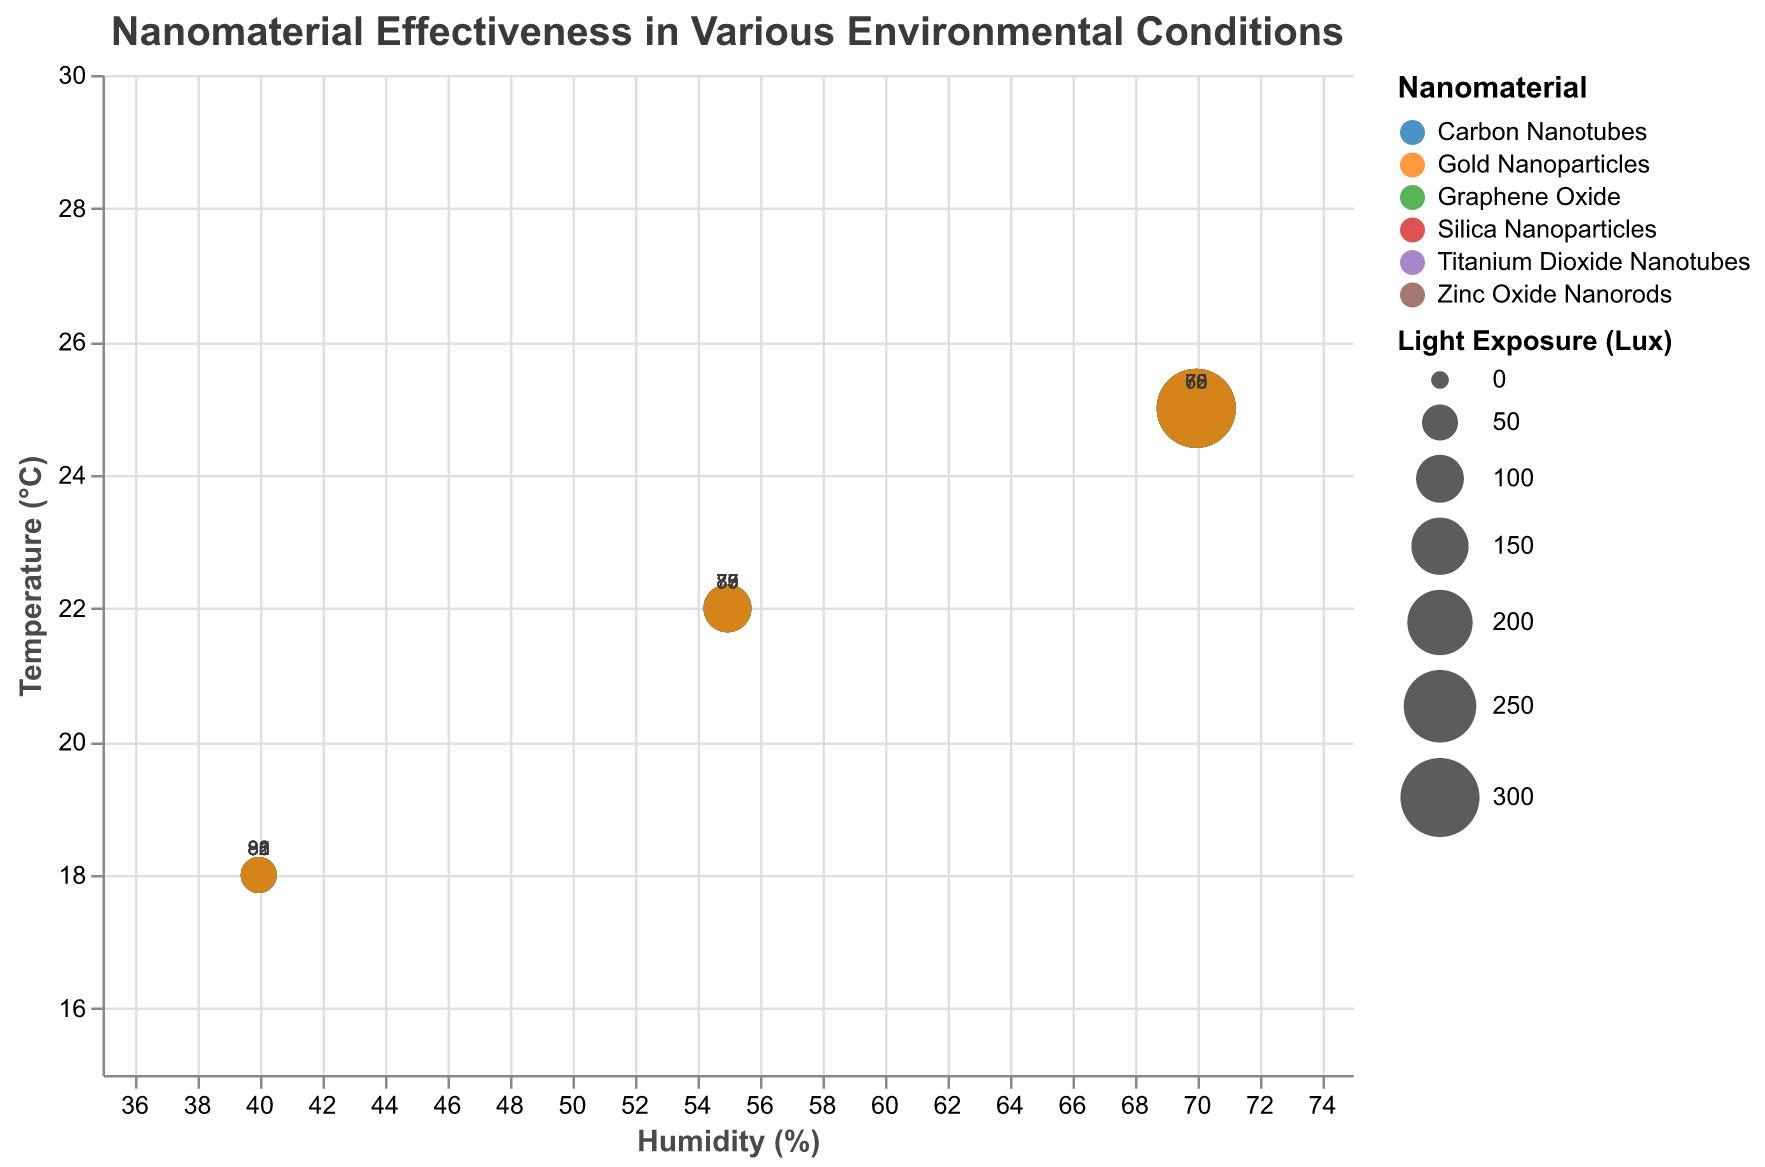What is the title of the figure? The title is typically found at the top of the chart and clearly states the purpose of the visualization.
Answer: "Nanomaterial Effectiveness in Various Environmental Conditions" What are the units of measurement used for the Y-axis? The units can be understood by reading the Y-axis label that provides information about the variable and its measurement unit.
Answer: °C Which nanomaterial has the highest effectiveness score at 40% humidity and 18°C temperature? Locate the points corresponding to 40% humidity and 18°C temperature and then identify the material with the highest effectiveness score among them.
Answer: Graphene Oxide How does the effectiveness score of Silica Nanoparticles change from 40% humidity to 70% humidity at a constant temperature of 18°C? Compare the effectiveness scores of Silica Nanoparticles at 40% and 70% humidity while keeping the temperature constant at 18°C and describe the change.
Answer: Decreases from 85 to 76 Which material has the largest bubble size at 70% humidity and 25°C temperature, and what does this imply about its light exposure? Find the material at 70% humidity and 25°C temperature with the largest bubble. The bubble size indicates the extent of light exposure.
Answer: Silica Nanoparticles; high light exposure (300 Lux) How many different types of nanomaterials are represented in the figure? Look at the legend or count distinct colors representing different nanomaterials in the chart.
Answer: 6 Which material shows the greatest variability in effectiveness scores across different environmental conditions? Compare the range of effectiveness scores for each material across all environmental conditions presented in the data.
Answer: Graphene Oxide At 55% humidity and 22°C temperature, which nanomaterial has the smallest bubble size and what is its light exposure? Locate the point corresponding to 55% humidity and 22°C temperature. Find the material with the smallest bubble size and note its light exposure.
Answer: Silica Nanoparticles; 100 Lux What general trend can be observed about the effectiveness of nanomaterials when humidity increases from 40% to 70% while the temperature is maintained at 25°C? Look at the effectiveness scores of different materials at 40% and 70% humidity with a constant temperature of 25°C to identify any trends or patterns.
Answer: Generally, effectiveness decreases Which material shows the highest effectiveness at the lowest light exposure and what is the light exposure value? Find the material with the highest effectiveness score where the light exposure (bubble size) is smallest.
Answer: Graphene Oxide; 50 Lux 